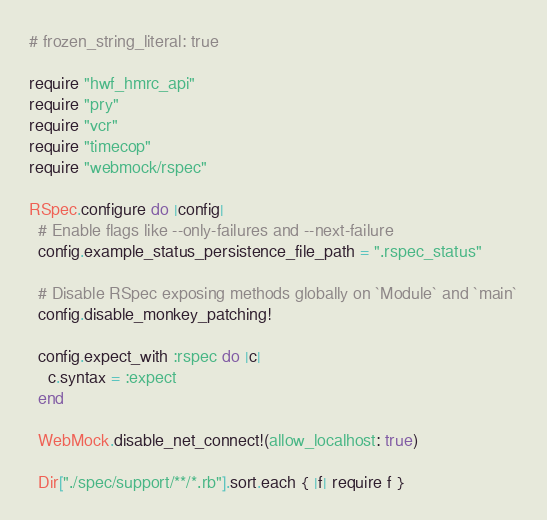Convert code to text. <code><loc_0><loc_0><loc_500><loc_500><_Ruby_># frozen_string_literal: true

require "hwf_hmrc_api"
require "pry"
require "vcr"
require "timecop"
require "webmock/rspec"

RSpec.configure do |config|
  # Enable flags like --only-failures and --next-failure
  config.example_status_persistence_file_path = ".rspec_status"

  # Disable RSpec exposing methods globally on `Module` and `main`
  config.disable_monkey_patching!

  config.expect_with :rspec do |c|
    c.syntax = :expect
  end

  WebMock.disable_net_connect!(allow_localhost: true)

  Dir["./spec/support/**/*.rb"].sort.each { |f| require f }</code> 